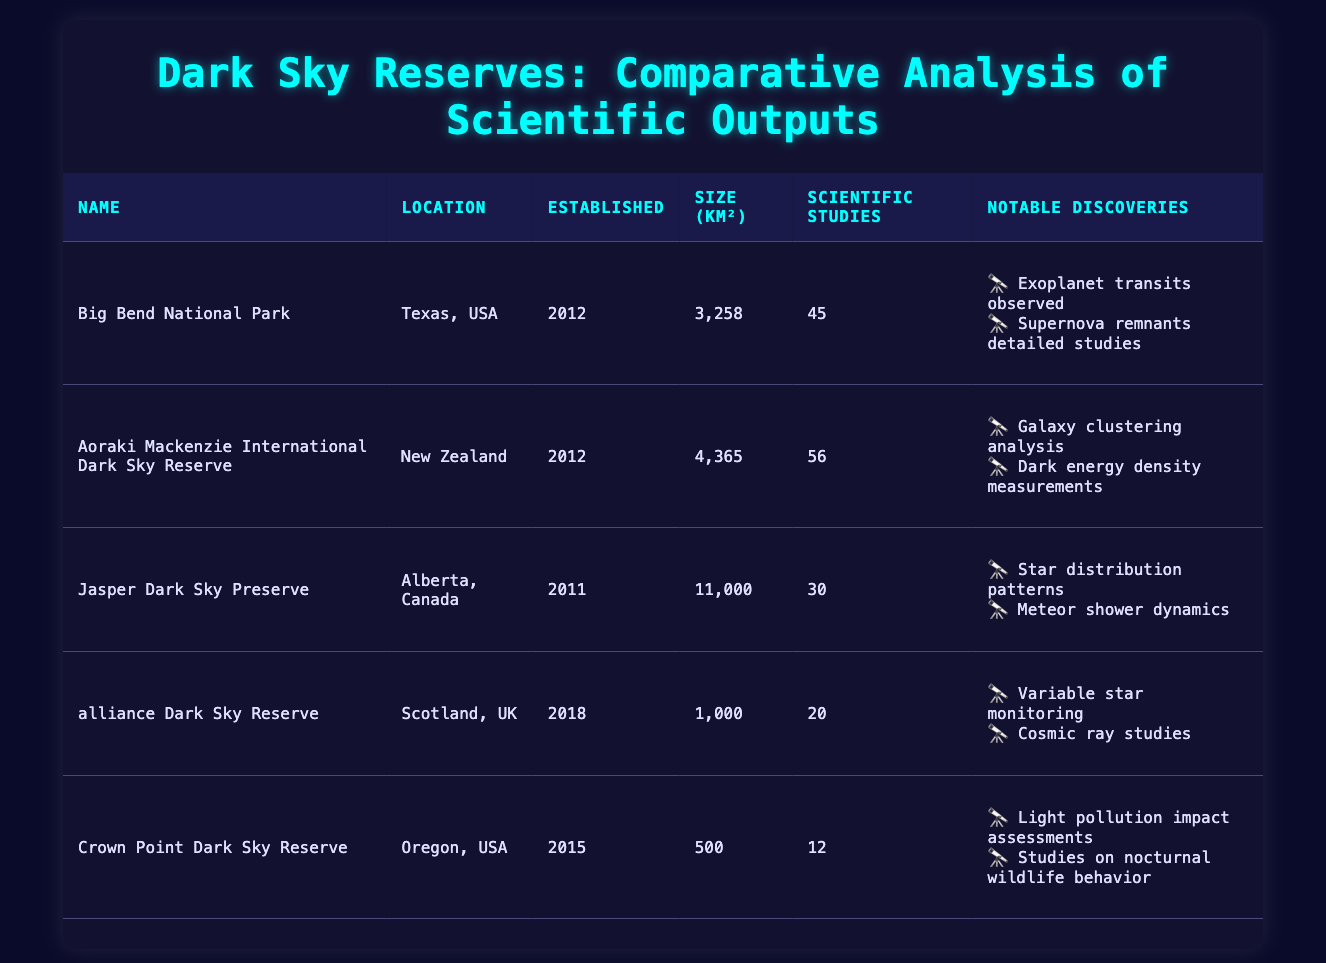What is the size of the Aoraki Mackenzie International Dark Sky Reserve? The table lists the size of the Aoraki Mackenzie International Dark Sky Reserve as 4,365 km² in the "Size (km²)" column.
Answer: 4,365 km² How many scientific studies were conducted in total across all dark sky reserves? To find the total number of scientific studies, I sum the studies from all reserves: 45 + 56 + 30 + 20 + 12 = 173.
Answer: 173 Is the Crown Point Dark Sky Reserve established after 2015? The table indicates that the Crown Point Dark Sky Reserve was established in 2015, so it is not established after that year.
Answer: No Which dark sky reserve has the largest number of scientific studies? By comparing the number of scientific studies in each reserve, Aoraki Mackenzie International Dark Sky Reserve has the most with 56 studies.
Answer: Aoraki Mackenzie International Dark Sky Reserve What is the average size of the dark sky reserves in km²? The total size of the reserves is 3,258 + 4,365 + 11,000 + 1,000 + 500 = 20,123 km². There are 5 reserves, so the average size is 20,123 ÷ 5 = 4,024.6 km².
Answer: 4,024.6 km² Are there any notable discoveries listed for the alliance Dark Sky Reserve? The table shows that the alliance Dark Sky Reserve has two notable discoveries listed, so the answer to whether there are notable discoveries is yes.
Answer: Yes Which dark sky reserve has both the smallest size and the least number of scientific studies? By examining the table, Crown Point Dark Sky Reserve has the smallest size (500 km²) and the least number of scientific studies (12).
Answer: Crown Point Dark Sky Reserve Which country has the most dark sky reserves listed in the table? I observe that the USA has two reserves (Big Bend National Park and Crown Point Dark Sky Reserve), while the other countries (New Zealand, Canada, and UK) have one each. Thus, the USA has the most reserves.
Answer: USA What is the total number of notable discoveries across all dark sky reserves? Counting the notable discoveries listed per reserve: Big Bend (2), Aoraki Mackenzie (2), Jasper (2), alliance (2), and Crown Point (2) gives a total of 2 + 2 + 2 + 2 + 2 = 10.
Answer: 10 